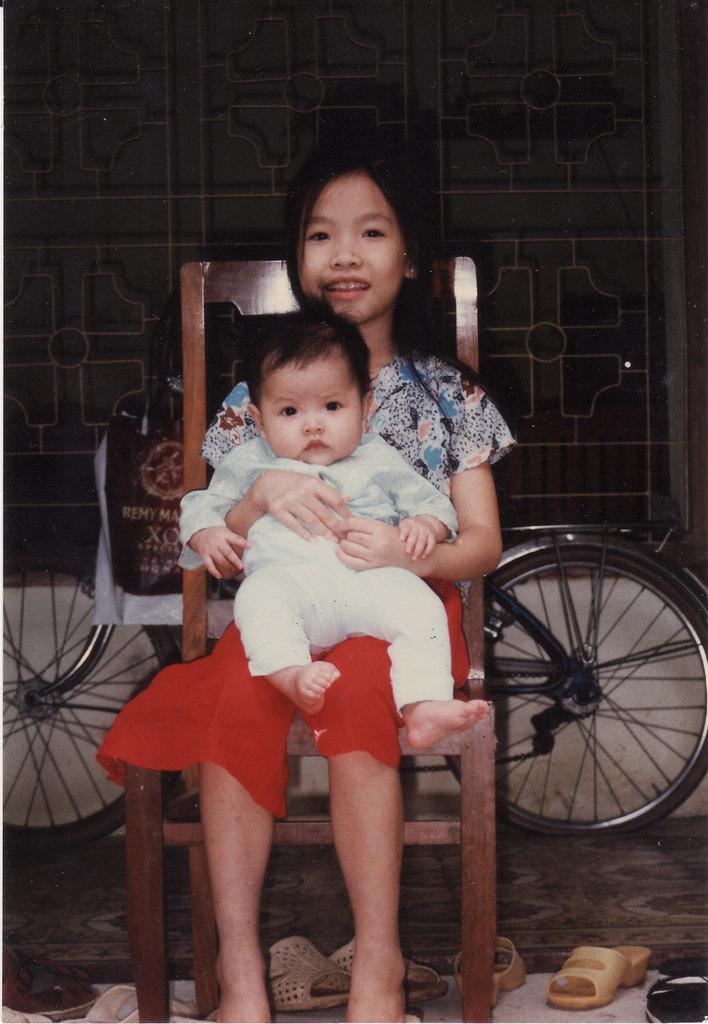Describe this image in one or two sentences. This girl is sitting on a wooden chair, above this girl there is a kids. Background there is a bicycle with bag in-front of this window. On floor there are chappals. 